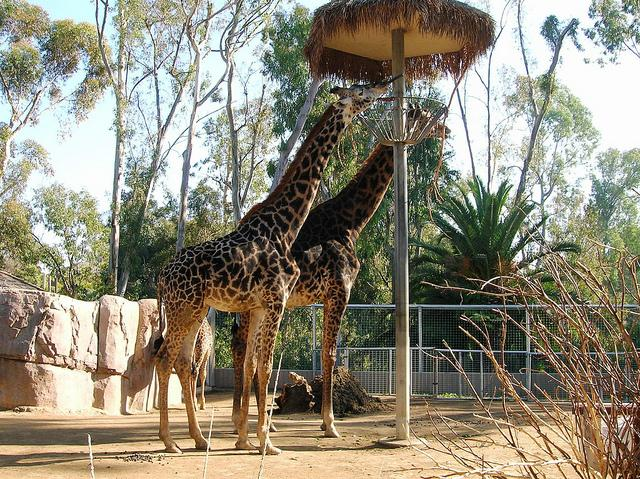What kind of fencing encloses these giraffes in the zoo? Please explain your reasoning. chain link. It is metal fencing 